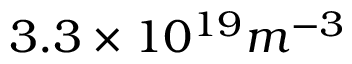Convert formula to latex. <formula><loc_0><loc_0><loc_500><loc_500>3 . 3 \times 1 0 ^ { 1 9 } m ^ { - 3 }</formula> 